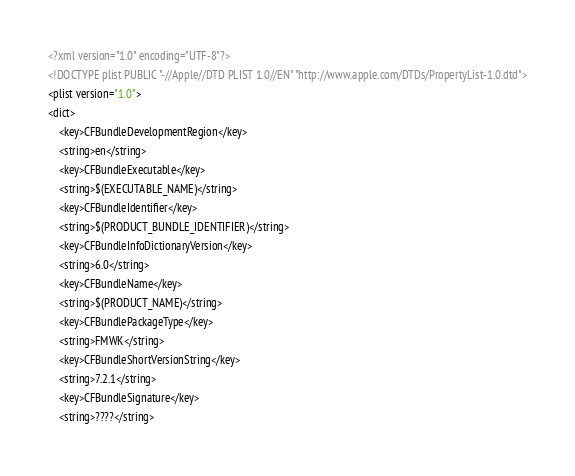Convert code to text. <code><loc_0><loc_0><loc_500><loc_500><_XML_><?xml version="1.0" encoding="UTF-8"?>
<!DOCTYPE plist PUBLIC "-//Apple//DTD PLIST 1.0//EN" "http://www.apple.com/DTDs/PropertyList-1.0.dtd">
<plist version="1.0">
<dict>
	<key>CFBundleDevelopmentRegion</key>
	<string>en</string>
	<key>CFBundleExecutable</key>
	<string>$(EXECUTABLE_NAME)</string>
	<key>CFBundleIdentifier</key>
	<string>$(PRODUCT_BUNDLE_IDENTIFIER)</string>
	<key>CFBundleInfoDictionaryVersion</key>
	<string>6.0</string>
	<key>CFBundleName</key>
	<string>$(PRODUCT_NAME)</string>
	<key>CFBundlePackageType</key>
	<string>FMWK</string>
	<key>CFBundleShortVersionString</key>
	<string>7.2.1</string>
	<key>CFBundleSignature</key>
	<string>????</string></code> 